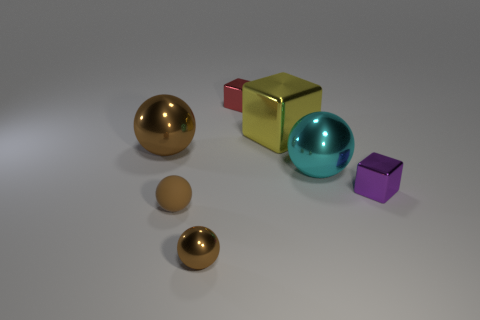Subtract all brown balls. How many were subtracted if there are1brown balls left? 2 Add 1 big yellow metallic blocks. How many objects exist? 8 Subtract all brown spheres. How many spheres are left? 1 Subtract all balls. How many objects are left? 3 Subtract 3 spheres. How many spheres are left? 1 Subtract all green blocks. Subtract all blue cylinders. How many blocks are left? 3 Subtract all gray balls. How many cyan blocks are left? 0 Subtract all tiny brown rubber things. Subtract all cyan shiny things. How many objects are left? 5 Add 6 large brown shiny spheres. How many large brown shiny spheres are left? 7 Add 5 large yellow rubber objects. How many large yellow rubber objects exist? 5 